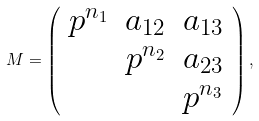<formula> <loc_0><loc_0><loc_500><loc_500>M = \left ( \begin{array} { c c c } p ^ { n _ { 1 } } & a _ { 1 2 } & a _ { 1 3 } \\ & p ^ { n _ { 2 } } & a _ { 2 3 } \\ & & p ^ { n _ { 3 } } \end{array} \right ) ,</formula> 